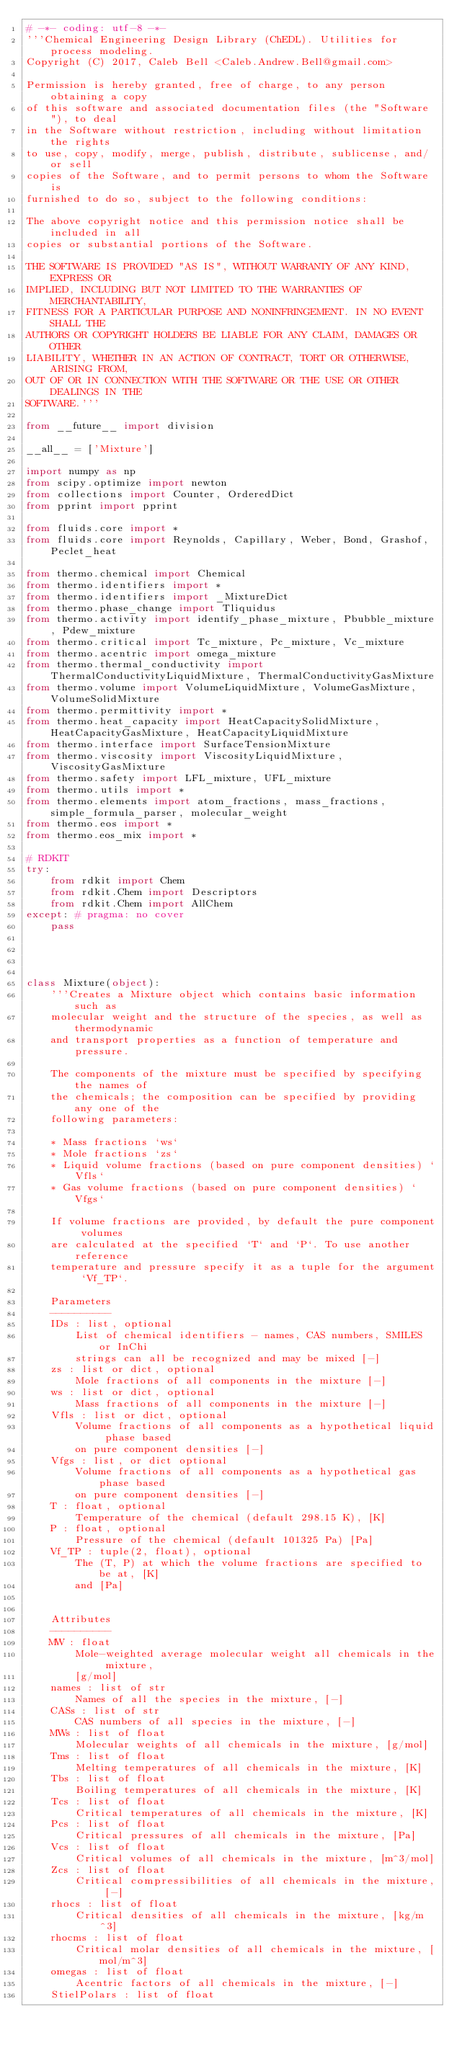<code> <loc_0><loc_0><loc_500><loc_500><_Python_># -*- coding: utf-8 -*-
'''Chemical Engineering Design Library (ChEDL). Utilities for process modeling.
Copyright (C) 2017, Caleb Bell <Caleb.Andrew.Bell@gmail.com>

Permission is hereby granted, free of charge, to any person obtaining a copy
of this software and associated documentation files (the "Software"), to deal
in the Software without restriction, including without limitation the rights
to use, copy, modify, merge, publish, distribute, sublicense, and/or sell
copies of the Software, and to permit persons to whom the Software is
furnished to do so, subject to the following conditions:

The above copyright notice and this permission notice shall be included in all
copies or substantial portions of the Software.

THE SOFTWARE IS PROVIDED "AS IS", WITHOUT WARRANTY OF ANY KIND, EXPRESS OR
IMPLIED, INCLUDING BUT NOT LIMITED TO THE WARRANTIES OF MERCHANTABILITY,
FITNESS FOR A PARTICULAR PURPOSE AND NONINFRINGEMENT. IN NO EVENT SHALL THE
AUTHORS OR COPYRIGHT HOLDERS BE LIABLE FOR ANY CLAIM, DAMAGES OR OTHER
LIABILITY, WHETHER IN AN ACTION OF CONTRACT, TORT OR OTHERWISE, ARISING FROM,
OUT OF OR IN CONNECTION WITH THE SOFTWARE OR THE USE OR OTHER DEALINGS IN THE
SOFTWARE.'''

from __future__ import division

__all__ = ['Mixture']

import numpy as np
from scipy.optimize import newton
from collections import Counter, OrderedDict
from pprint import pprint

from fluids.core import *
from fluids.core import Reynolds, Capillary, Weber, Bond, Grashof, Peclet_heat

from thermo.chemical import Chemical
from thermo.identifiers import *
from thermo.identifiers import _MixtureDict
from thermo.phase_change import Tliquidus
from thermo.activity import identify_phase_mixture, Pbubble_mixture, Pdew_mixture
from thermo.critical import Tc_mixture, Pc_mixture, Vc_mixture
from thermo.acentric import omega_mixture
from thermo.thermal_conductivity import ThermalConductivityLiquidMixture, ThermalConductivityGasMixture
from thermo.volume import VolumeLiquidMixture, VolumeGasMixture, VolumeSolidMixture
from thermo.permittivity import *
from thermo.heat_capacity import HeatCapacitySolidMixture, HeatCapacityGasMixture, HeatCapacityLiquidMixture
from thermo.interface import SurfaceTensionMixture
from thermo.viscosity import ViscosityLiquidMixture, ViscosityGasMixture
from thermo.safety import LFL_mixture, UFL_mixture
from thermo.utils import *
from thermo.elements import atom_fractions, mass_fractions, simple_formula_parser, molecular_weight
from thermo.eos import *
from thermo.eos_mix import *

# RDKIT
try:
    from rdkit import Chem
    from rdkit.Chem import Descriptors
    from rdkit.Chem import AllChem
except: # pragma: no cover
    pass




class Mixture(object): 
    '''Creates a Mixture object which contains basic information such as 
    molecular weight and the structure of the species, as well as thermodynamic
    and transport properties as a function of temperature and pressure.
    
    The components of the mixture must be specified by specifying the names of
    the chemicals; the composition can be specified by providing any one of the
    following parameters:
        
    * Mass fractions `ws`
    * Mole fractions `zs`
    * Liquid volume fractions (based on pure component densities) `Vfls`
    * Gas volume fractions (based on pure component densities) `Vfgs`
    
    If volume fractions are provided, by default the pure component volumes
    are calculated at the specified `T` and `P`. To use another reference 
    temperature and pressure specify it as a tuple for the argument `Vf_TP`. 

    Parameters
    ----------
    IDs : list, optional
        List of chemical identifiers - names, CAS numbers, SMILES or InChi 
        strings can all be recognized and may be mixed [-]
    zs : list or dict, optional
        Mole fractions of all components in the mixture [-]
    ws : list or dict, optional
        Mass fractions of all components in the mixture [-]
    Vfls : list or dict, optional
        Volume fractions of all components as a hypothetical liquid phase based 
        on pure component densities [-]
    Vfgs : list, or dict optional
        Volume fractions of all components as a hypothetical gas phase based 
        on pure component densities [-]
    T : float, optional
        Temperature of the chemical (default 298.15 K), [K]
    P : float, optional
        Pressure of the chemical (default 101325 Pa) [Pa]
    Vf_TP : tuple(2, float), optional
        The (T, P) at which the volume fractions are specified to be at, [K] 
        and [Pa]
    
    
    Attributes
    ----------
    MW : float
        Mole-weighted average molecular weight all chemicals in the mixture, 
        [g/mol]
    names : list of str
        Names of all the species in the mixture, [-]
    CASs : list of str
        CAS numbers of all species in the mixture, [-]
    MWs : list of float
        Molecular weights of all chemicals in the mixture, [g/mol]
    Tms : list of float
        Melting temperatures of all chemicals in the mixture, [K]
    Tbs : list of float
        Boiling temperatures of all chemicals in the mixture, [K]
    Tcs : list of float
        Critical temperatures of all chemicals in the mixture, [K]
    Pcs : list of float
        Critical pressures of all chemicals in the mixture, [Pa]
    Vcs : list of float
        Critical volumes of all chemicals in the mixture, [m^3/mol]
    Zcs : list of float
        Critical compressibilities of all chemicals in the mixture, [-]
    rhocs : list of float
        Critical densities of all chemicals in the mixture, [kg/m^3]
    rhocms : list of float
        Critical molar densities of all chemicals in the mixture, [mol/m^3]
    omegas : list of float
        Acentric factors of all chemicals in the mixture, [-]
    StielPolars : list of float</code> 